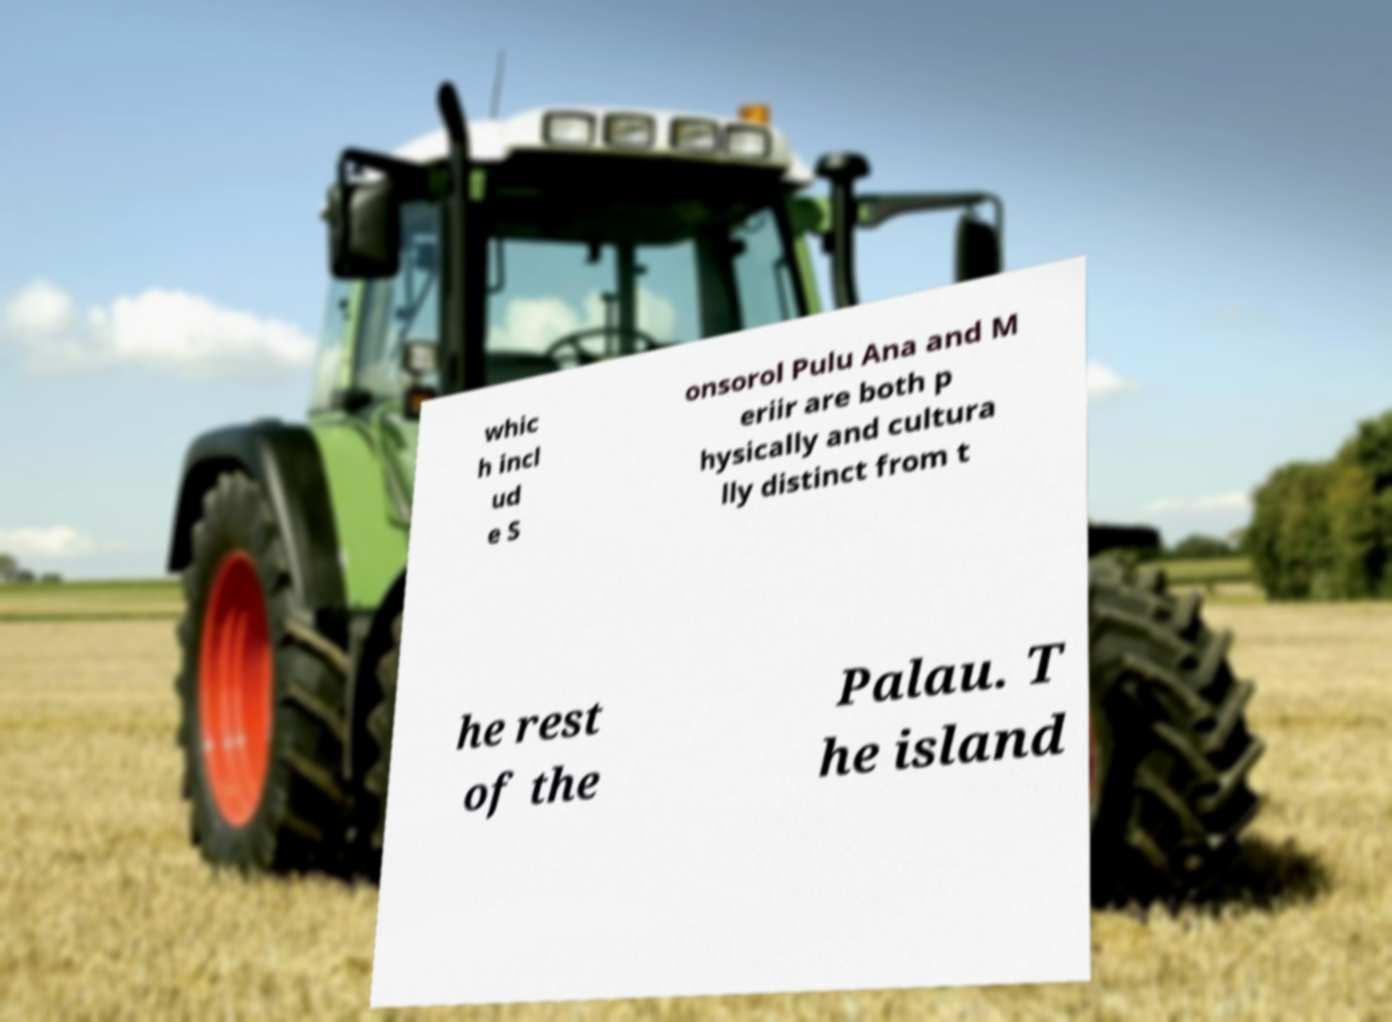Please identify and transcribe the text found in this image. whic h incl ud e S onsorol Pulu Ana and M eriir are both p hysically and cultura lly distinct from t he rest of the Palau. T he island 